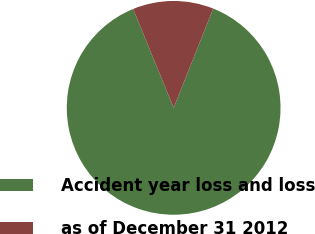Convert chart. <chart><loc_0><loc_0><loc_500><loc_500><pie_chart><fcel>Accident year loss and loss<fcel>as of December 31 2012<nl><fcel>87.78%<fcel>12.22%<nl></chart> 